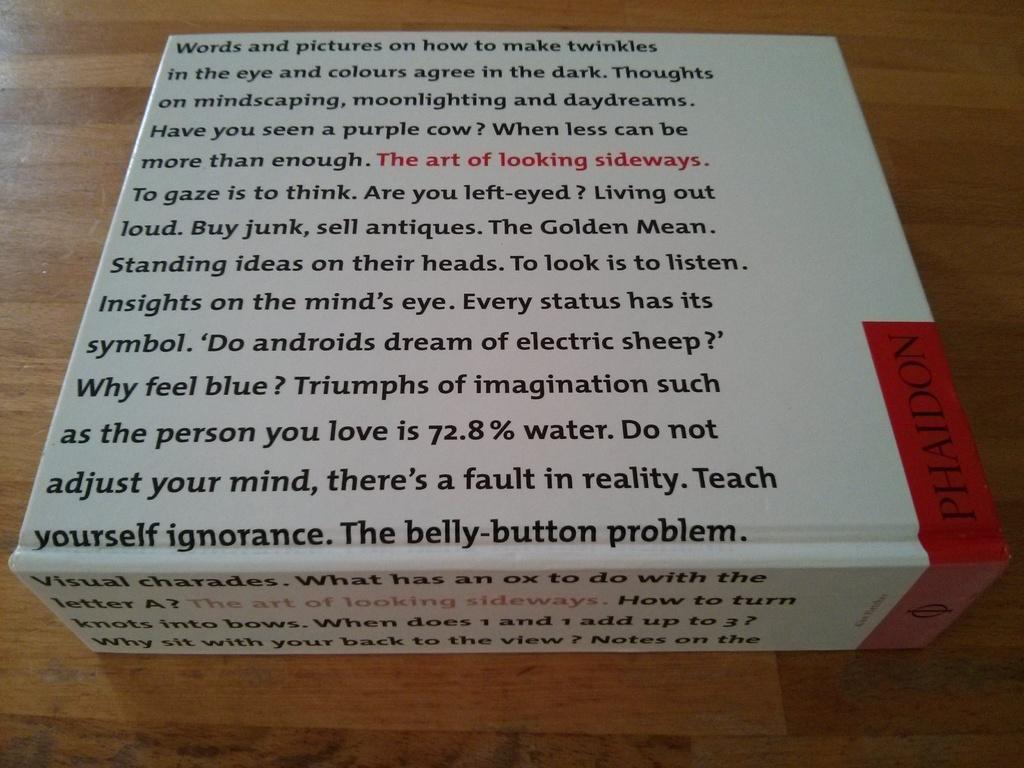What percentage of water is the person you love?
Your answer should be very brief. 72.8. What is called this art?
Provide a short and direct response. The art of looking sideways. 